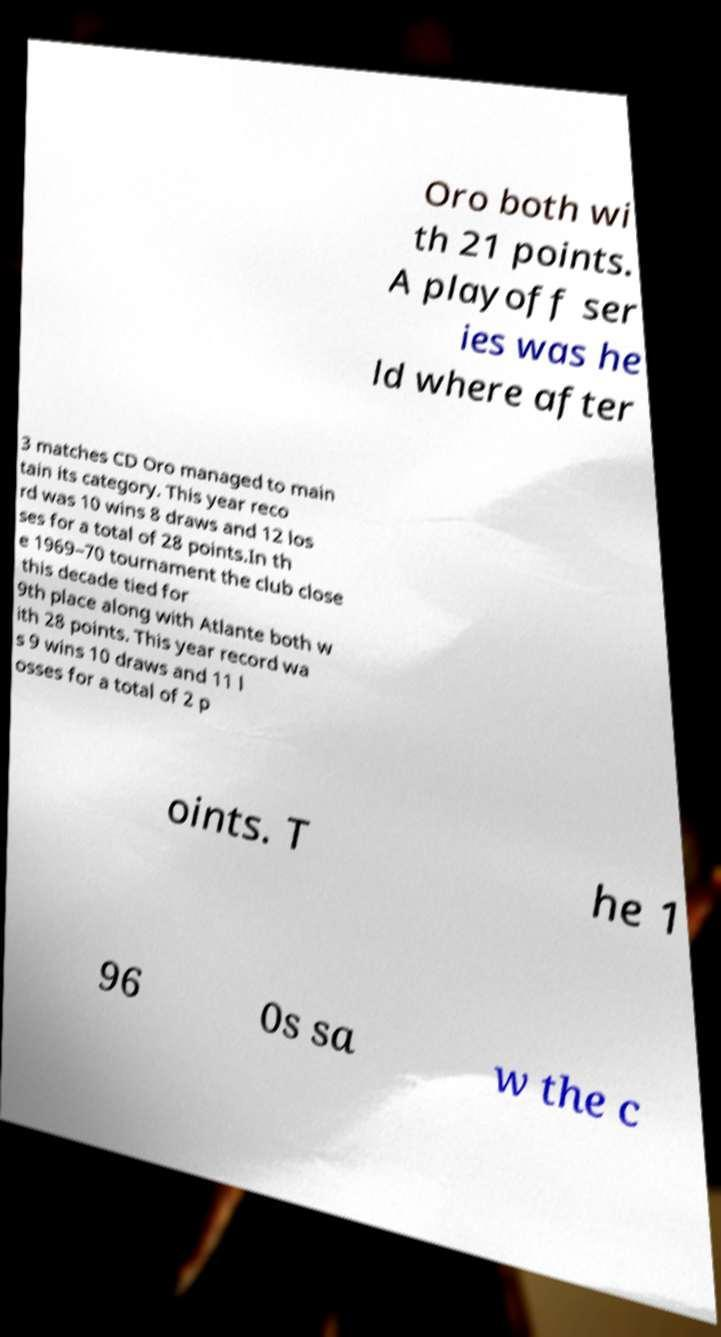Can you accurately transcribe the text from the provided image for me? Oro both wi th 21 points. A playoff ser ies was he ld where after 3 matches CD Oro managed to main tain its category. This year reco rd was 10 wins 8 draws and 12 los ses for a total of 28 points.In th e 1969–70 tournament the club close this decade tied for 9th place along with Atlante both w ith 28 points. This year record wa s 9 wins 10 draws and 11 l osses for a total of 2 p oints. T he 1 96 0s sa w the c 